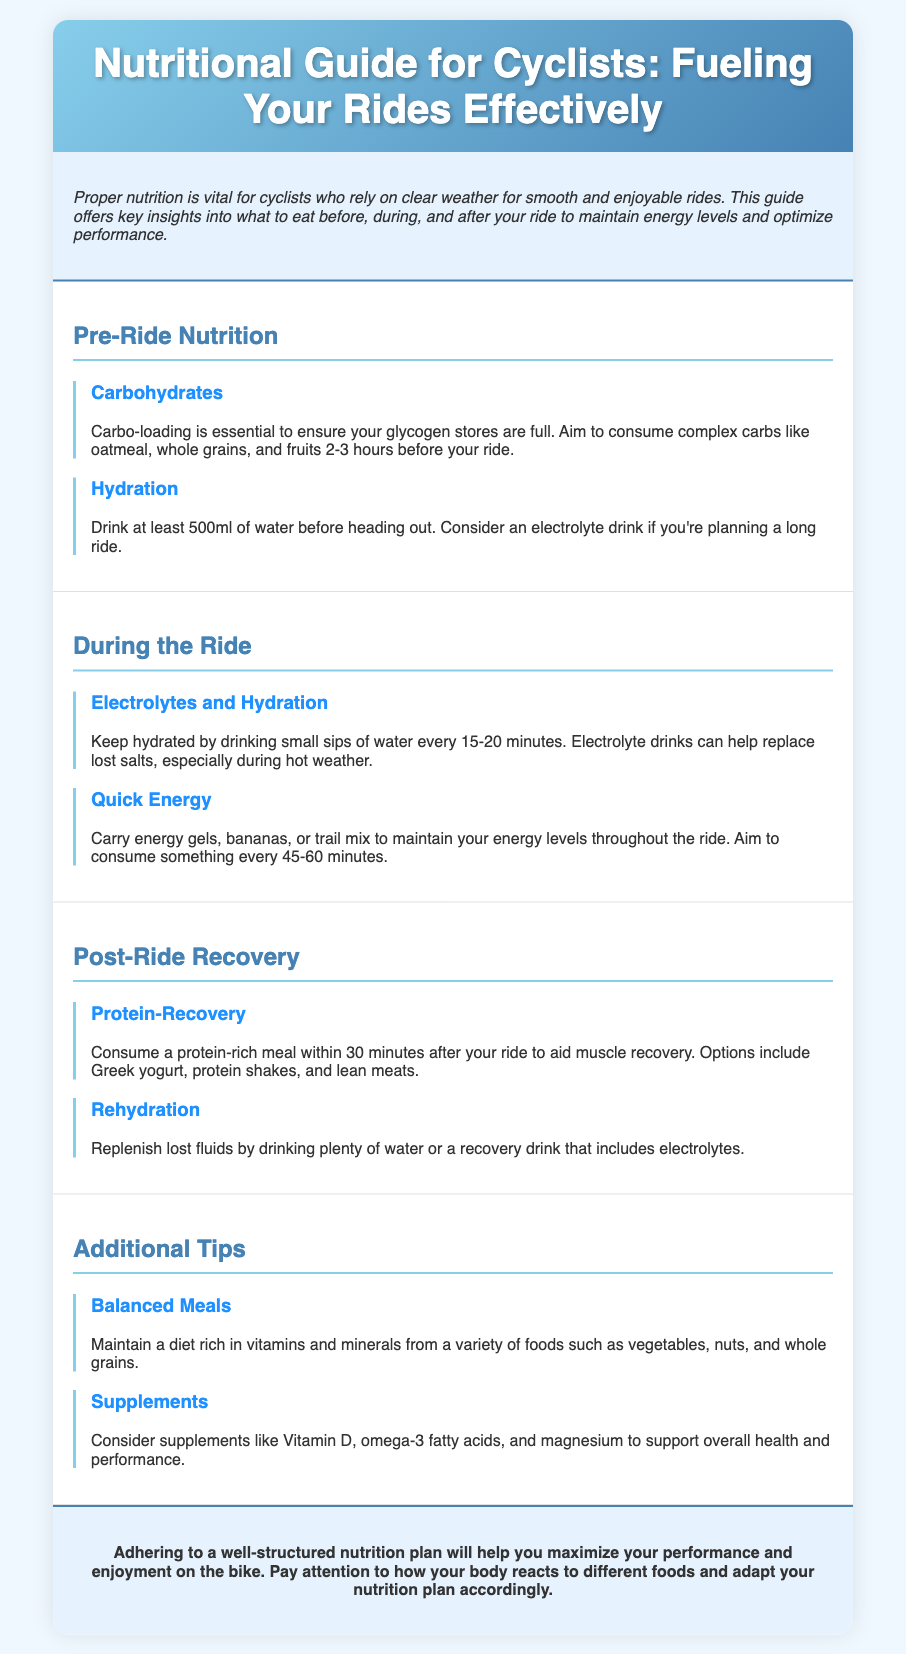What is the main focus of the guide? The guide emphasizes the importance of proper nutrition for cyclists by explaining what to eat before, during, and after rides.
Answer: Proper nutrition How many hours before a ride should you consume complex carbs? The document specifies the time frame for eating complex carbs before a ride.
Answer: 2-3 hours What should you drink at least 500ml of before riding? The guide mentions a specific drink to consume before biking.
Answer: Water How often should you hydrate during the ride? The document explains the recommended hydration frequency during rides.
Answer: Every 15-20 minutes What type of meal is suggested post-ride for protein recovery? The guide gives examples of protein-rich food to consume after riding.
Answer: Protein-rich meal What foods does the guide recommend for quick energy during rides? The document lists specific foods beneficial for maintaining energy while cycling.
Answer: Energy gels, bananas, trail mix What type of meals should cyclists maintain? The guide highlights the importance of overall meal quality for cyclists.
Answer: Balanced meals Which supplements does the guide suggest considering? The document lists specific supplements that may benefit cyclists' overall health.
Answer: Vitamin D, omega-3 fatty acids, magnesium 